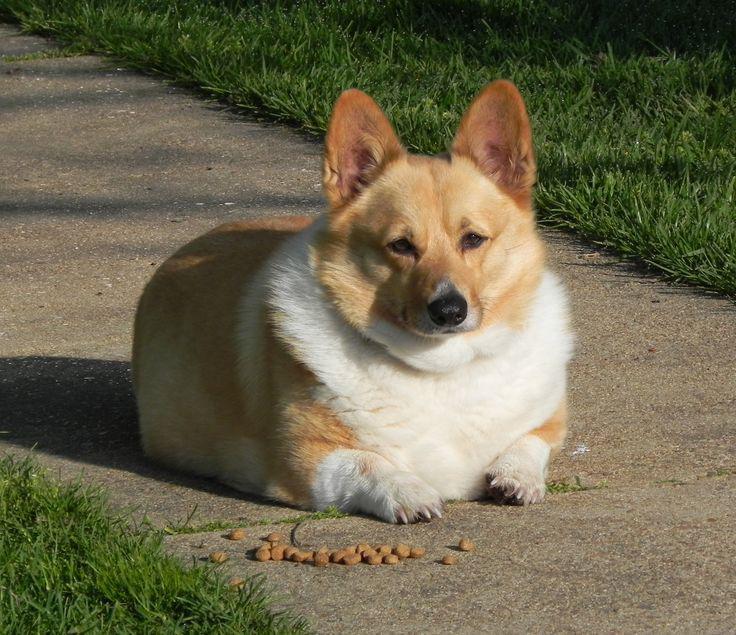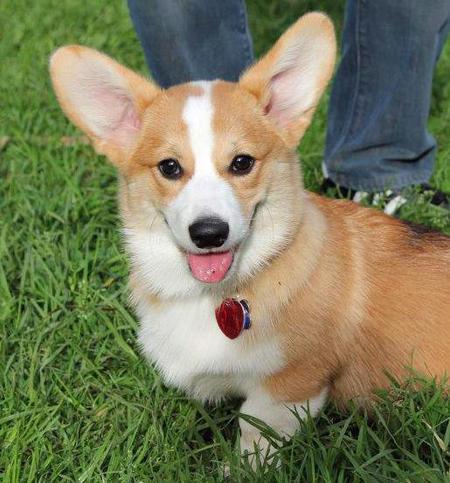The first image is the image on the left, the second image is the image on the right. Given the left and right images, does the statement "A dog in the image on the left is lying down with its tongue hanging out." hold true? Answer yes or no. No. The first image is the image on the left, the second image is the image on the right. Given the left and right images, does the statement "The corgi's are outside laying in or near the green grass" hold true? Answer yes or no. Yes. 